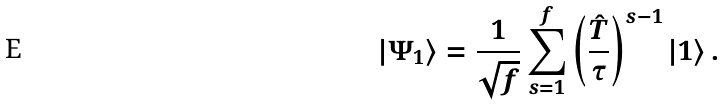Convert formula to latex. <formula><loc_0><loc_0><loc_500><loc_500>| \Psi _ { 1 } \rangle = \frac { 1 } { \sqrt { f } } \sum _ { s = 1 } ^ { f } \left ( \frac { \hat { T } } { \tau } \right ) ^ { s - 1 } | 1 \rangle \, .</formula> 